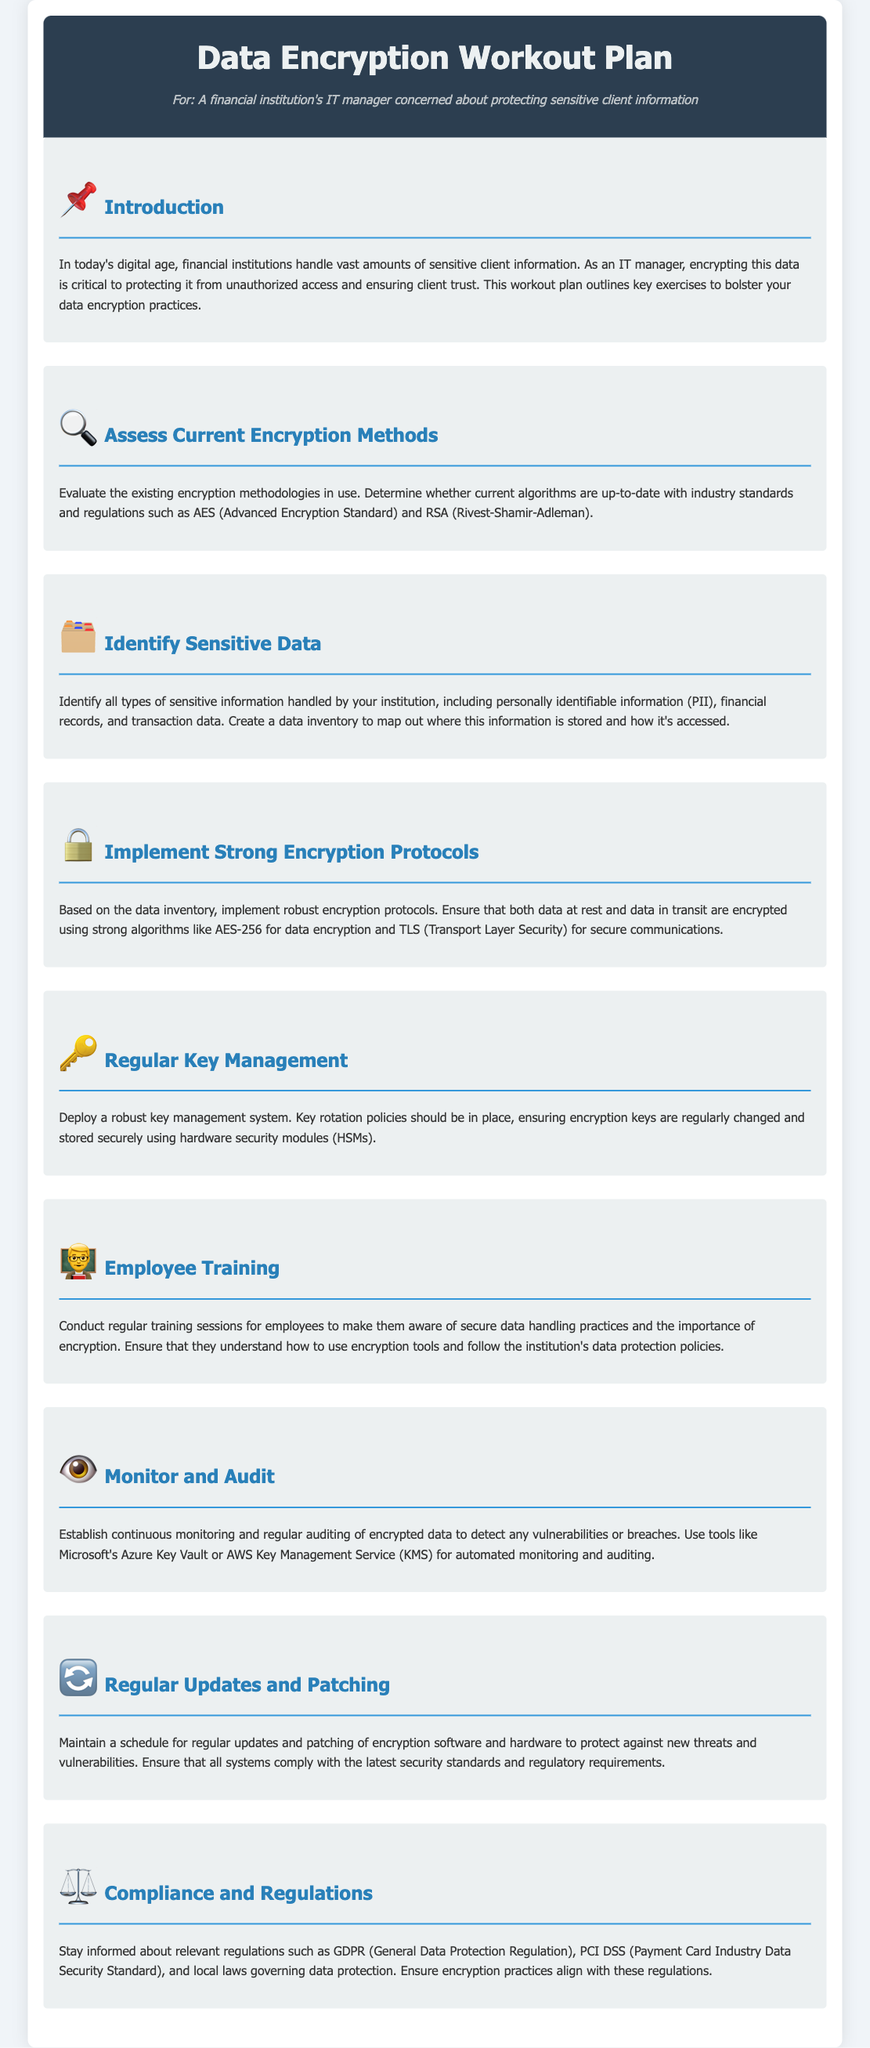What is the title of the document? The title is prominently displayed at the top of the document under the header section.
Answer: Data Encryption Workout Plan What is one encryption algorithm mentioned? The document lists algorithms that are considered industry standards for data encryption.
Answer: AES What type of data should be identified according to the plan? The section focuses on types of information that need special attention for encryption.
Answer: Sensitive Information What protocol is recommended for secure communications? The document suggests a specific protocol for securing data in transit.
Answer: TLS How should encryption keys be managed? The document describes a system for handling encryption keys securely.
Answer: Key Management System What is the purpose of employee training? The document highlights the importance of training employees regarding data encryption practices.
Answer: Secure Data Handling Practices Which regulatory compliance is mentioned? The document refers to specific regulations that govern data protection in financial institutions.
Answer: GDPR What should be established for encrypted data? The document emphasizes a procedure to ensure the security of encrypted data.
Answer: Continuous Monitoring What kind of updates does the document suggest for encryption software? The document suggests maintaining security by implementing a routine for certain updates.
Answer: Regular Updates and Patching 